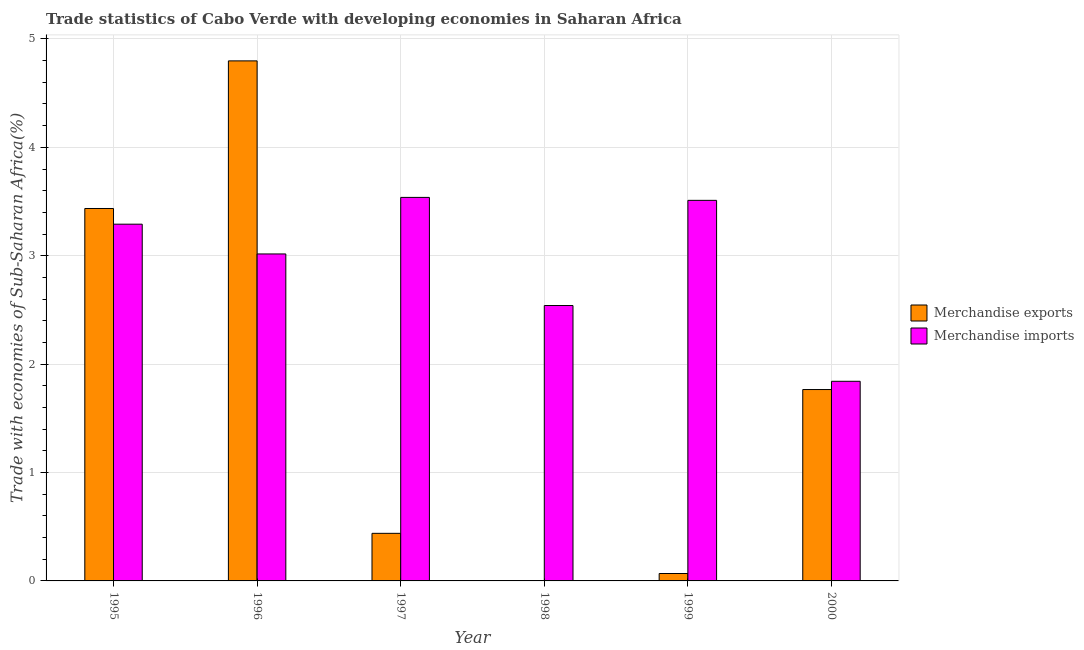How many different coloured bars are there?
Your response must be concise. 2. How many bars are there on the 4th tick from the left?
Your response must be concise. 2. How many bars are there on the 3rd tick from the right?
Provide a succinct answer. 2. In how many cases, is the number of bars for a given year not equal to the number of legend labels?
Ensure brevity in your answer.  0. What is the merchandise imports in 1999?
Give a very brief answer. 3.51. Across all years, what is the maximum merchandise imports?
Keep it short and to the point. 3.54. Across all years, what is the minimum merchandise imports?
Your response must be concise. 1.84. In which year was the merchandise exports minimum?
Your answer should be very brief. 1998. What is the total merchandise imports in the graph?
Offer a terse response. 17.74. What is the difference between the merchandise exports in 1997 and that in 1998?
Offer a terse response. 0.44. What is the difference between the merchandise exports in 2000 and the merchandise imports in 1999?
Ensure brevity in your answer.  1.7. What is the average merchandise exports per year?
Make the answer very short. 1.75. In the year 1996, what is the difference between the merchandise imports and merchandise exports?
Your answer should be compact. 0. What is the ratio of the merchandise imports in 1995 to that in 1998?
Offer a very short reply. 1.3. Is the difference between the merchandise imports in 1997 and 1999 greater than the difference between the merchandise exports in 1997 and 1999?
Make the answer very short. No. What is the difference between the highest and the second highest merchandise imports?
Your response must be concise. 0.03. What is the difference between the highest and the lowest merchandise exports?
Offer a terse response. 4.8. What does the 2nd bar from the left in 1997 represents?
Your response must be concise. Merchandise imports. What does the 2nd bar from the right in 1999 represents?
Keep it short and to the point. Merchandise exports. How many bars are there?
Provide a succinct answer. 12. Are all the bars in the graph horizontal?
Keep it short and to the point. No. What is the difference between two consecutive major ticks on the Y-axis?
Provide a short and direct response. 1. Does the graph contain any zero values?
Keep it short and to the point. No. Where does the legend appear in the graph?
Your answer should be compact. Center right. How many legend labels are there?
Ensure brevity in your answer.  2. How are the legend labels stacked?
Provide a succinct answer. Vertical. What is the title of the graph?
Your answer should be compact. Trade statistics of Cabo Verde with developing economies in Saharan Africa. Does "Exports" appear as one of the legend labels in the graph?
Your response must be concise. No. What is the label or title of the X-axis?
Your answer should be very brief. Year. What is the label or title of the Y-axis?
Your answer should be very brief. Trade with economies of Sub-Saharan Africa(%). What is the Trade with economies of Sub-Saharan Africa(%) of Merchandise exports in 1995?
Ensure brevity in your answer.  3.44. What is the Trade with economies of Sub-Saharan Africa(%) in Merchandise imports in 1995?
Provide a succinct answer. 3.29. What is the Trade with economies of Sub-Saharan Africa(%) in Merchandise exports in 1996?
Your response must be concise. 4.8. What is the Trade with economies of Sub-Saharan Africa(%) of Merchandise imports in 1996?
Your answer should be very brief. 3.02. What is the Trade with economies of Sub-Saharan Africa(%) of Merchandise exports in 1997?
Make the answer very short. 0.44. What is the Trade with economies of Sub-Saharan Africa(%) of Merchandise imports in 1997?
Make the answer very short. 3.54. What is the Trade with economies of Sub-Saharan Africa(%) of Merchandise exports in 1998?
Provide a succinct answer. 0. What is the Trade with economies of Sub-Saharan Africa(%) in Merchandise imports in 1998?
Your response must be concise. 2.54. What is the Trade with economies of Sub-Saharan Africa(%) of Merchandise exports in 1999?
Give a very brief answer. 0.07. What is the Trade with economies of Sub-Saharan Africa(%) in Merchandise imports in 1999?
Make the answer very short. 3.51. What is the Trade with economies of Sub-Saharan Africa(%) in Merchandise exports in 2000?
Your answer should be compact. 1.77. What is the Trade with economies of Sub-Saharan Africa(%) in Merchandise imports in 2000?
Ensure brevity in your answer.  1.84. Across all years, what is the maximum Trade with economies of Sub-Saharan Africa(%) of Merchandise exports?
Your response must be concise. 4.8. Across all years, what is the maximum Trade with economies of Sub-Saharan Africa(%) in Merchandise imports?
Make the answer very short. 3.54. Across all years, what is the minimum Trade with economies of Sub-Saharan Africa(%) of Merchandise exports?
Provide a short and direct response. 0. Across all years, what is the minimum Trade with economies of Sub-Saharan Africa(%) of Merchandise imports?
Keep it short and to the point. 1.84. What is the total Trade with economies of Sub-Saharan Africa(%) in Merchandise exports in the graph?
Provide a succinct answer. 10.51. What is the total Trade with economies of Sub-Saharan Africa(%) of Merchandise imports in the graph?
Make the answer very short. 17.74. What is the difference between the Trade with economies of Sub-Saharan Africa(%) in Merchandise exports in 1995 and that in 1996?
Make the answer very short. -1.36. What is the difference between the Trade with economies of Sub-Saharan Africa(%) of Merchandise imports in 1995 and that in 1996?
Offer a terse response. 0.27. What is the difference between the Trade with economies of Sub-Saharan Africa(%) of Merchandise exports in 1995 and that in 1997?
Provide a short and direct response. 3. What is the difference between the Trade with economies of Sub-Saharan Africa(%) of Merchandise imports in 1995 and that in 1997?
Offer a terse response. -0.25. What is the difference between the Trade with economies of Sub-Saharan Africa(%) of Merchandise exports in 1995 and that in 1998?
Your answer should be compact. 3.43. What is the difference between the Trade with economies of Sub-Saharan Africa(%) of Merchandise imports in 1995 and that in 1998?
Offer a terse response. 0.75. What is the difference between the Trade with economies of Sub-Saharan Africa(%) in Merchandise exports in 1995 and that in 1999?
Keep it short and to the point. 3.37. What is the difference between the Trade with economies of Sub-Saharan Africa(%) of Merchandise imports in 1995 and that in 1999?
Your response must be concise. -0.22. What is the difference between the Trade with economies of Sub-Saharan Africa(%) in Merchandise exports in 1995 and that in 2000?
Offer a terse response. 1.67. What is the difference between the Trade with economies of Sub-Saharan Africa(%) in Merchandise imports in 1995 and that in 2000?
Provide a succinct answer. 1.45. What is the difference between the Trade with economies of Sub-Saharan Africa(%) in Merchandise exports in 1996 and that in 1997?
Your response must be concise. 4.36. What is the difference between the Trade with economies of Sub-Saharan Africa(%) in Merchandise imports in 1996 and that in 1997?
Your response must be concise. -0.52. What is the difference between the Trade with economies of Sub-Saharan Africa(%) of Merchandise exports in 1996 and that in 1998?
Provide a succinct answer. 4.8. What is the difference between the Trade with economies of Sub-Saharan Africa(%) of Merchandise imports in 1996 and that in 1998?
Ensure brevity in your answer.  0.48. What is the difference between the Trade with economies of Sub-Saharan Africa(%) in Merchandise exports in 1996 and that in 1999?
Keep it short and to the point. 4.73. What is the difference between the Trade with economies of Sub-Saharan Africa(%) in Merchandise imports in 1996 and that in 1999?
Your answer should be compact. -0.49. What is the difference between the Trade with economies of Sub-Saharan Africa(%) of Merchandise exports in 1996 and that in 2000?
Offer a terse response. 3.03. What is the difference between the Trade with economies of Sub-Saharan Africa(%) of Merchandise imports in 1996 and that in 2000?
Keep it short and to the point. 1.17. What is the difference between the Trade with economies of Sub-Saharan Africa(%) of Merchandise exports in 1997 and that in 1998?
Provide a short and direct response. 0.44. What is the difference between the Trade with economies of Sub-Saharan Africa(%) of Merchandise imports in 1997 and that in 1998?
Your response must be concise. 1. What is the difference between the Trade with economies of Sub-Saharan Africa(%) of Merchandise exports in 1997 and that in 1999?
Make the answer very short. 0.37. What is the difference between the Trade with economies of Sub-Saharan Africa(%) in Merchandise imports in 1997 and that in 1999?
Provide a short and direct response. 0.03. What is the difference between the Trade with economies of Sub-Saharan Africa(%) in Merchandise exports in 1997 and that in 2000?
Your response must be concise. -1.33. What is the difference between the Trade with economies of Sub-Saharan Africa(%) of Merchandise imports in 1997 and that in 2000?
Your answer should be very brief. 1.7. What is the difference between the Trade with economies of Sub-Saharan Africa(%) of Merchandise exports in 1998 and that in 1999?
Provide a short and direct response. -0.07. What is the difference between the Trade with economies of Sub-Saharan Africa(%) in Merchandise imports in 1998 and that in 1999?
Your response must be concise. -0.97. What is the difference between the Trade with economies of Sub-Saharan Africa(%) of Merchandise exports in 1998 and that in 2000?
Offer a very short reply. -1.76. What is the difference between the Trade with economies of Sub-Saharan Africa(%) in Merchandise imports in 1998 and that in 2000?
Your answer should be very brief. 0.7. What is the difference between the Trade with economies of Sub-Saharan Africa(%) in Merchandise exports in 1999 and that in 2000?
Provide a short and direct response. -1.7. What is the difference between the Trade with economies of Sub-Saharan Africa(%) in Merchandise imports in 1999 and that in 2000?
Keep it short and to the point. 1.67. What is the difference between the Trade with economies of Sub-Saharan Africa(%) in Merchandise exports in 1995 and the Trade with economies of Sub-Saharan Africa(%) in Merchandise imports in 1996?
Keep it short and to the point. 0.42. What is the difference between the Trade with economies of Sub-Saharan Africa(%) of Merchandise exports in 1995 and the Trade with economies of Sub-Saharan Africa(%) of Merchandise imports in 1997?
Keep it short and to the point. -0.1. What is the difference between the Trade with economies of Sub-Saharan Africa(%) of Merchandise exports in 1995 and the Trade with economies of Sub-Saharan Africa(%) of Merchandise imports in 1998?
Make the answer very short. 0.9. What is the difference between the Trade with economies of Sub-Saharan Africa(%) of Merchandise exports in 1995 and the Trade with economies of Sub-Saharan Africa(%) of Merchandise imports in 1999?
Make the answer very short. -0.08. What is the difference between the Trade with economies of Sub-Saharan Africa(%) in Merchandise exports in 1995 and the Trade with economies of Sub-Saharan Africa(%) in Merchandise imports in 2000?
Provide a succinct answer. 1.59. What is the difference between the Trade with economies of Sub-Saharan Africa(%) of Merchandise exports in 1996 and the Trade with economies of Sub-Saharan Africa(%) of Merchandise imports in 1997?
Your answer should be compact. 1.26. What is the difference between the Trade with economies of Sub-Saharan Africa(%) of Merchandise exports in 1996 and the Trade with economies of Sub-Saharan Africa(%) of Merchandise imports in 1998?
Your answer should be very brief. 2.26. What is the difference between the Trade with economies of Sub-Saharan Africa(%) of Merchandise exports in 1996 and the Trade with economies of Sub-Saharan Africa(%) of Merchandise imports in 1999?
Give a very brief answer. 1.29. What is the difference between the Trade with economies of Sub-Saharan Africa(%) in Merchandise exports in 1996 and the Trade with economies of Sub-Saharan Africa(%) in Merchandise imports in 2000?
Your answer should be very brief. 2.96. What is the difference between the Trade with economies of Sub-Saharan Africa(%) in Merchandise exports in 1997 and the Trade with economies of Sub-Saharan Africa(%) in Merchandise imports in 1998?
Provide a short and direct response. -2.1. What is the difference between the Trade with economies of Sub-Saharan Africa(%) of Merchandise exports in 1997 and the Trade with economies of Sub-Saharan Africa(%) of Merchandise imports in 1999?
Make the answer very short. -3.07. What is the difference between the Trade with economies of Sub-Saharan Africa(%) in Merchandise exports in 1997 and the Trade with economies of Sub-Saharan Africa(%) in Merchandise imports in 2000?
Provide a succinct answer. -1.4. What is the difference between the Trade with economies of Sub-Saharan Africa(%) of Merchandise exports in 1998 and the Trade with economies of Sub-Saharan Africa(%) of Merchandise imports in 1999?
Your answer should be compact. -3.51. What is the difference between the Trade with economies of Sub-Saharan Africa(%) of Merchandise exports in 1998 and the Trade with economies of Sub-Saharan Africa(%) of Merchandise imports in 2000?
Give a very brief answer. -1.84. What is the difference between the Trade with economies of Sub-Saharan Africa(%) in Merchandise exports in 1999 and the Trade with economies of Sub-Saharan Africa(%) in Merchandise imports in 2000?
Keep it short and to the point. -1.77. What is the average Trade with economies of Sub-Saharan Africa(%) in Merchandise exports per year?
Offer a very short reply. 1.75. What is the average Trade with economies of Sub-Saharan Africa(%) of Merchandise imports per year?
Keep it short and to the point. 2.96. In the year 1995, what is the difference between the Trade with economies of Sub-Saharan Africa(%) of Merchandise exports and Trade with economies of Sub-Saharan Africa(%) of Merchandise imports?
Ensure brevity in your answer.  0.14. In the year 1996, what is the difference between the Trade with economies of Sub-Saharan Africa(%) in Merchandise exports and Trade with economies of Sub-Saharan Africa(%) in Merchandise imports?
Offer a very short reply. 1.78. In the year 1997, what is the difference between the Trade with economies of Sub-Saharan Africa(%) of Merchandise exports and Trade with economies of Sub-Saharan Africa(%) of Merchandise imports?
Offer a terse response. -3.1. In the year 1998, what is the difference between the Trade with economies of Sub-Saharan Africa(%) in Merchandise exports and Trade with economies of Sub-Saharan Africa(%) in Merchandise imports?
Provide a short and direct response. -2.54. In the year 1999, what is the difference between the Trade with economies of Sub-Saharan Africa(%) in Merchandise exports and Trade with economies of Sub-Saharan Africa(%) in Merchandise imports?
Offer a terse response. -3.44. In the year 2000, what is the difference between the Trade with economies of Sub-Saharan Africa(%) of Merchandise exports and Trade with economies of Sub-Saharan Africa(%) of Merchandise imports?
Your answer should be compact. -0.08. What is the ratio of the Trade with economies of Sub-Saharan Africa(%) in Merchandise exports in 1995 to that in 1996?
Give a very brief answer. 0.72. What is the ratio of the Trade with economies of Sub-Saharan Africa(%) of Merchandise imports in 1995 to that in 1996?
Provide a succinct answer. 1.09. What is the ratio of the Trade with economies of Sub-Saharan Africa(%) in Merchandise exports in 1995 to that in 1997?
Make the answer very short. 7.83. What is the ratio of the Trade with economies of Sub-Saharan Africa(%) in Merchandise imports in 1995 to that in 1997?
Provide a short and direct response. 0.93. What is the ratio of the Trade with economies of Sub-Saharan Africa(%) in Merchandise exports in 1995 to that in 1998?
Your answer should be very brief. 2494.27. What is the ratio of the Trade with economies of Sub-Saharan Africa(%) of Merchandise imports in 1995 to that in 1998?
Offer a very short reply. 1.3. What is the ratio of the Trade with economies of Sub-Saharan Africa(%) of Merchandise exports in 1995 to that in 1999?
Your response must be concise. 50.2. What is the ratio of the Trade with economies of Sub-Saharan Africa(%) in Merchandise imports in 1995 to that in 1999?
Give a very brief answer. 0.94. What is the ratio of the Trade with economies of Sub-Saharan Africa(%) in Merchandise exports in 1995 to that in 2000?
Ensure brevity in your answer.  1.95. What is the ratio of the Trade with economies of Sub-Saharan Africa(%) in Merchandise imports in 1995 to that in 2000?
Provide a short and direct response. 1.79. What is the ratio of the Trade with economies of Sub-Saharan Africa(%) of Merchandise exports in 1996 to that in 1997?
Offer a terse response. 10.93. What is the ratio of the Trade with economies of Sub-Saharan Africa(%) in Merchandise imports in 1996 to that in 1997?
Provide a succinct answer. 0.85. What is the ratio of the Trade with economies of Sub-Saharan Africa(%) in Merchandise exports in 1996 to that in 1998?
Provide a short and direct response. 3482.96. What is the ratio of the Trade with economies of Sub-Saharan Africa(%) in Merchandise imports in 1996 to that in 1998?
Offer a terse response. 1.19. What is the ratio of the Trade with economies of Sub-Saharan Africa(%) in Merchandise exports in 1996 to that in 1999?
Offer a very short reply. 70.09. What is the ratio of the Trade with economies of Sub-Saharan Africa(%) in Merchandise imports in 1996 to that in 1999?
Give a very brief answer. 0.86. What is the ratio of the Trade with economies of Sub-Saharan Africa(%) of Merchandise exports in 1996 to that in 2000?
Your answer should be compact. 2.72. What is the ratio of the Trade with economies of Sub-Saharan Africa(%) in Merchandise imports in 1996 to that in 2000?
Your answer should be very brief. 1.64. What is the ratio of the Trade with economies of Sub-Saharan Africa(%) of Merchandise exports in 1997 to that in 1998?
Offer a terse response. 318.71. What is the ratio of the Trade with economies of Sub-Saharan Africa(%) of Merchandise imports in 1997 to that in 1998?
Make the answer very short. 1.39. What is the ratio of the Trade with economies of Sub-Saharan Africa(%) of Merchandise exports in 1997 to that in 1999?
Keep it short and to the point. 6.41. What is the ratio of the Trade with economies of Sub-Saharan Africa(%) of Merchandise imports in 1997 to that in 1999?
Keep it short and to the point. 1.01. What is the ratio of the Trade with economies of Sub-Saharan Africa(%) of Merchandise exports in 1997 to that in 2000?
Give a very brief answer. 0.25. What is the ratio of the Trade with economies of Sub-Saharan Africa(%) of Merchandise imports in 1997 to that in 2000?
Your answer should be very brief. 1.92. What is the ratio of the Trade with economies of Sub-Saharan Africa(%) in Merchandise exports in 1998 to that in 1999?
Provide a succinct answer. 0.02. What is the ratio of the Trade with economies of Sub-Saharan Africa(%) of Merchandise imports in 1998 to that in 1999?
Provide a short and direct response. 0.72. What is the ratio of the Trade with economies of Sub-Saharan Africa(%) in Merchandise exports in 1998 to that in 2000?
Ensure brevity in your answer.  0. What is the ratio of the Trade with economies of Sub-Saharan Africa(%) in Merchandise imports in 1998 to that in 2000?
Your response must be concise. 1.38. What is the ratio of the Trade with economies of Sub-Saharan Africa(%) in Merchandise exports in 1999 to that in 2000?
Your answer should be very brief. 0.04. What is the ratio of the Trade with economies of Sub-Saharan Africa(%) in Merchandise imports in 1999 to that in 2000?
Offer a very short reply. 1.91. What is the difference between the highest and the second highest Trade with economies of Sub-Saharan Africa(%) in Merchandise exports?
Give a very brief answer. 1.36. What is the difference between the highest and the second highest Trade with economies of Sub-Saharan Africa(%) of Merchandise imports?
Offer a terse response. 0.03. What is the difference between the highest and the lowest Trade with economies of Sub-Saharan Africa(%) of Merchandise exports?
Provide a short and direct response. 4.8. What is the difference between the highest and the lowest Trade with economies of Sub-Saharan Africa(%) in Merchandise imports?
Give a very brief answer. 1.7. 